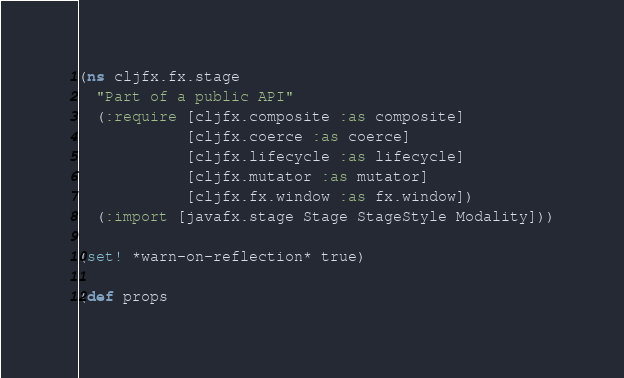<code> <loc_0><loc_0><loc_500><loc_500><_Clojure_>(ns cljfx.fx.stage
  "Part of a public API"
  (:require [cljfx.composite :as composite]
            [cljfx.coerce :as coerce]
            [cljfx.lifecycle :as lifecycle]
            [cljfx.mutator :as mutator]
            [cljfx.fx.window :as fx.window])
  (:import [javafx.stage Stage StageStyle Modality]))

(set! *warn-on-reflection* true)

(def props</code> 